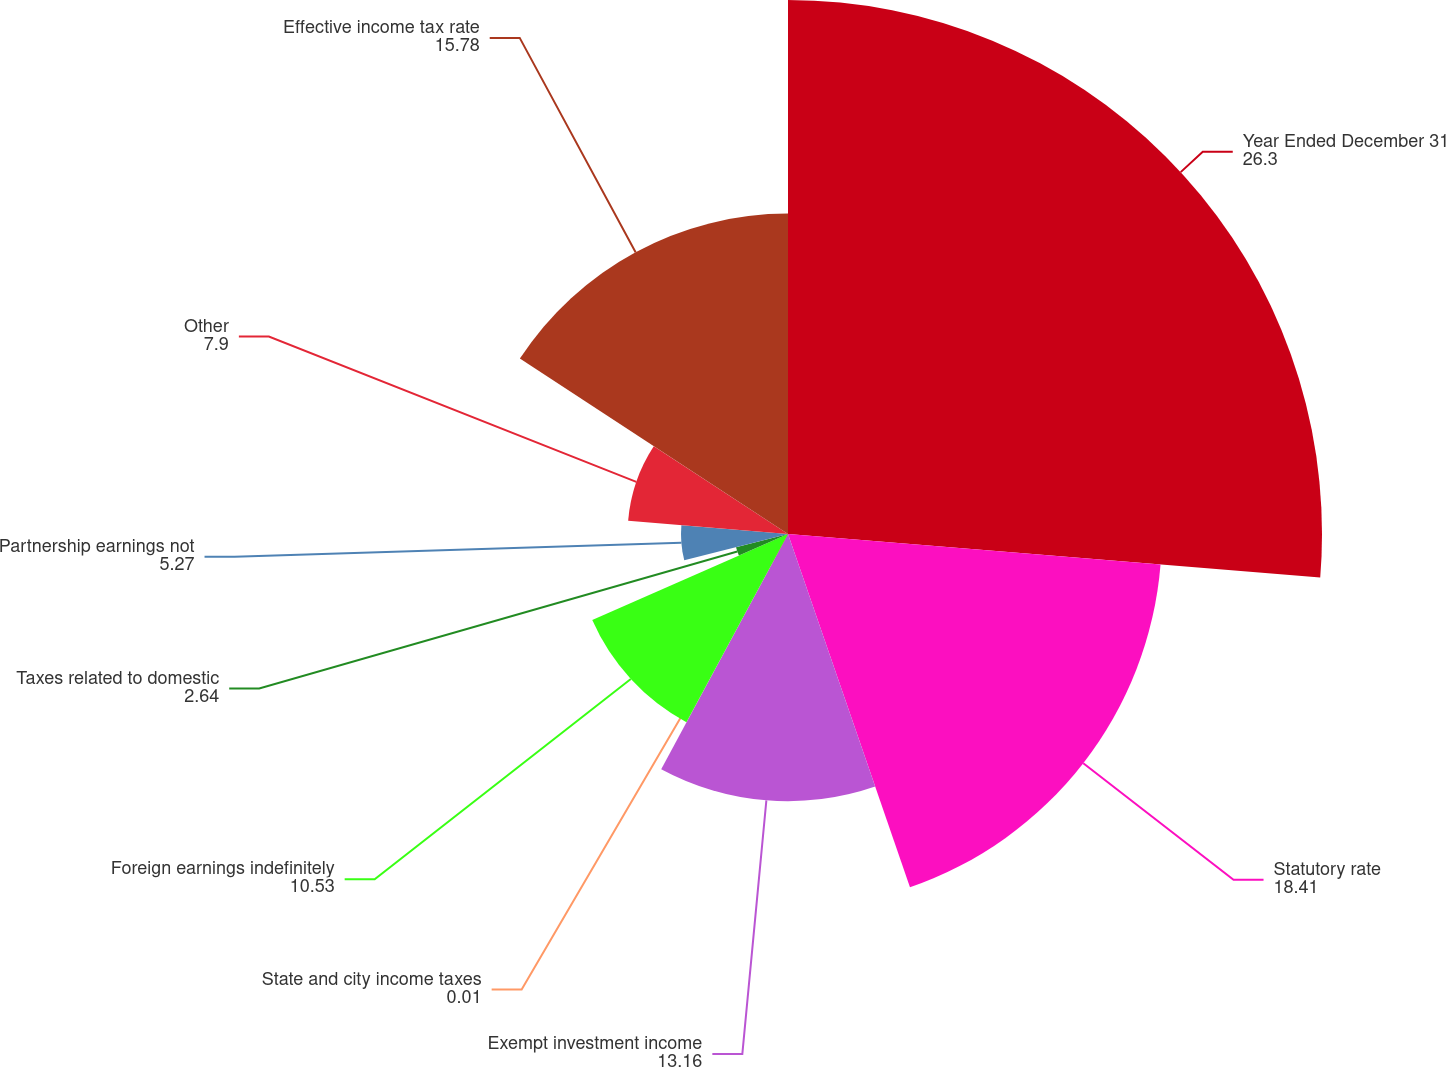<chart> <loc_0><loc_0><loc_500><loc_500><pie_chart><fcel>Year Ended December 31<fcel>Statutory rate<fcel>Exempt investment income<fcel>State and city income taxes<fcel>Foreign earnings indefinitely<fcel>Taxes related to domestic<fcel>Partnership earnings not<fcel>Other<fcel>Effective income tax rate<nl><fcel>26.3%<fcel>18.41%<fcel>13.16%<fcel>0.01%<fcel>10.53%<fcel>2.64%<fcel>5.27%<fcel>7.9%<fcel>15.78%<nl></chart> 